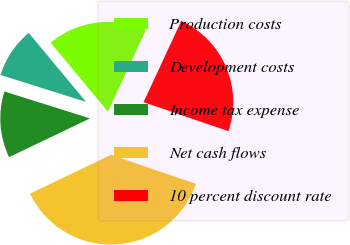<chart> <loc_0><loc_0><loc_500><loc_500><pie_chart><fcel>Production costs<fcel>Development costs<fcel>Income tax expense<fcel>Net cash flows<fcel>10 percent discount rate<nl><fcel>17.95%<fcel>9.11%<fcel>11.96%<fcel>37.66%<fcel>23.32%<nl></chart> 